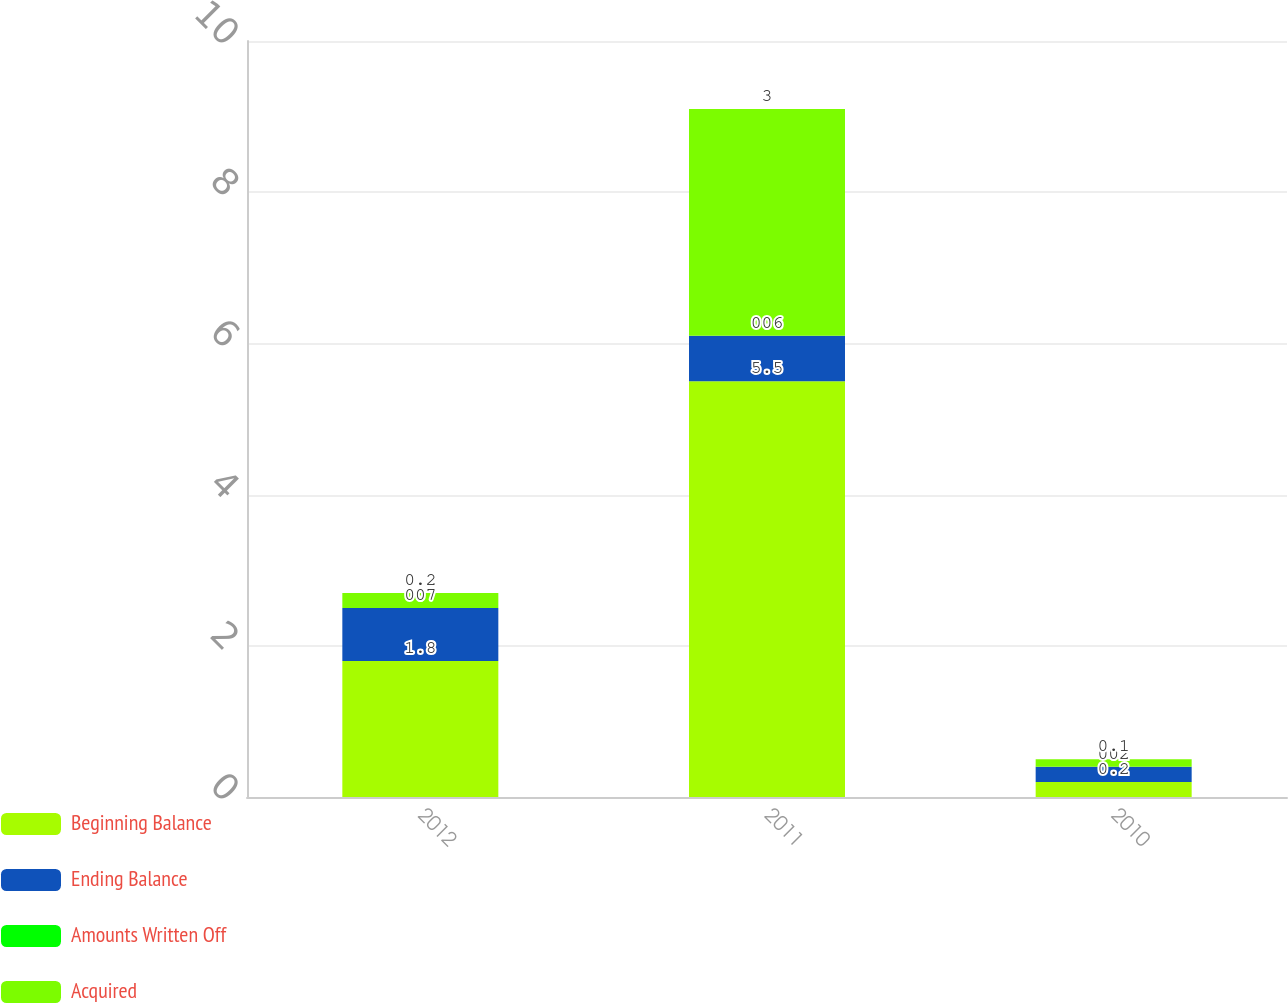Convert chart to OTSL. <chart><loc_0><loc_0><loc_500><loc_500><stacked_bar_chart><ecel><fcel>2012<fcel>2011<fcel>2010<nl><fcel>Beginning Balance<fcel>1.8<fcel>5.5<fcel>0.2<nl><fcel>Ending Balance<fcel>0.7<fcel>0.6<fcel>0.2<nl><fcel>Amounts Written Off<fcel>0<fcel>0<fcel>0<nl><fcel>Acquired<fcel>0.2<fcel>3<fcel>0.1<nl></chart> 